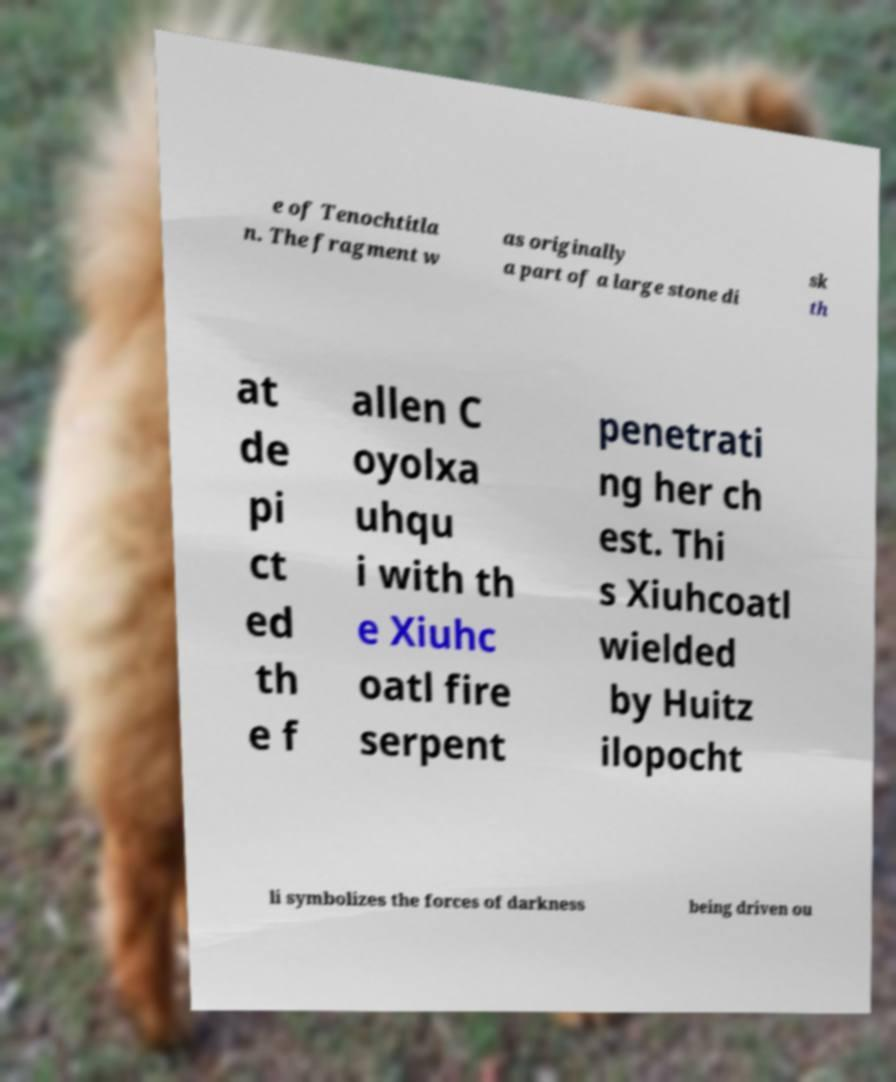I need the written content from this picture converted into text. Can you do that? e of Tenochtitla n. The fragment w as originally a part of a large stone di sk th at de pi ct ed th e f allen C oyolxa uhqu i with th e Xiuhc oatl fire serpent penetrati ng her ch est. Thi s Xiuhcoatl wielded by Huitz ilopocht li symbolizes the forces of darkness being driven ou 